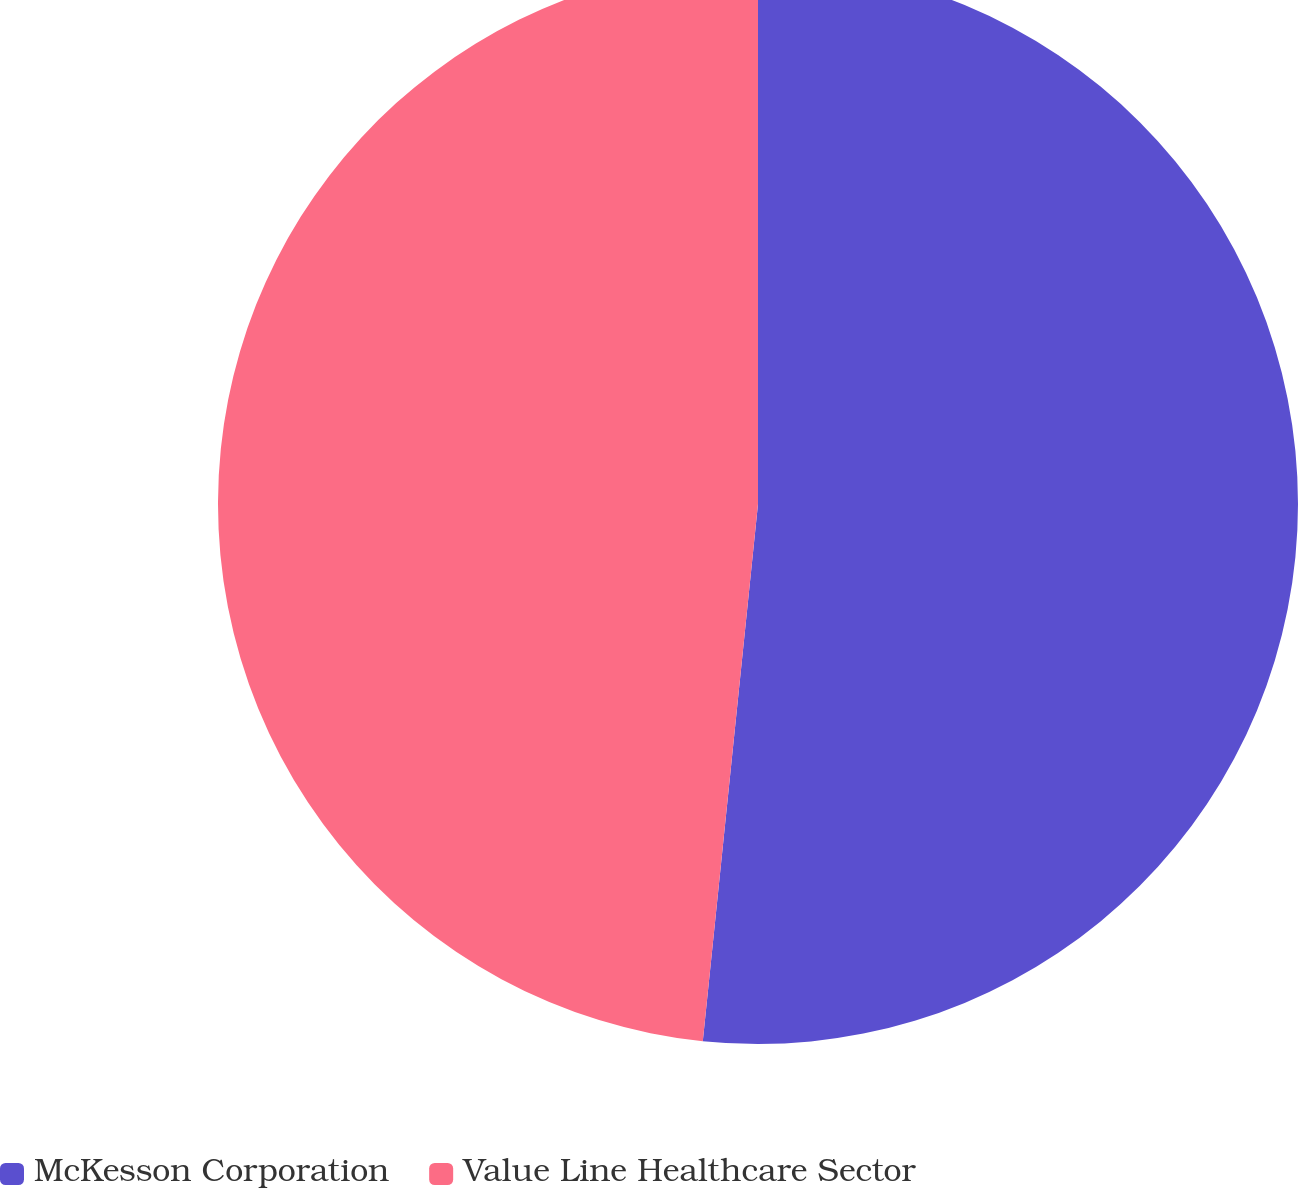Convert chart to OTSL. <chart><loc_0><loc_0><loc_500><loc_500><pie_chart><fcel>McKesson Corporation<fcel>Value Line Healthcare Sector<nl><fcel>51.63%<fcel>48.37%<nl></chart> 